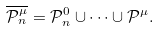Convert formula to latex. <formula><loc_0><loc_0><loc_500><loc_500>\overline { { \mathcal { P } } ^ { \mu } _ { n } } = { \mathcal { P } } ^ { 0 } _ { n } \cup \dots \cup { \mathcal { P } } ^ { \mu } .</formula> 